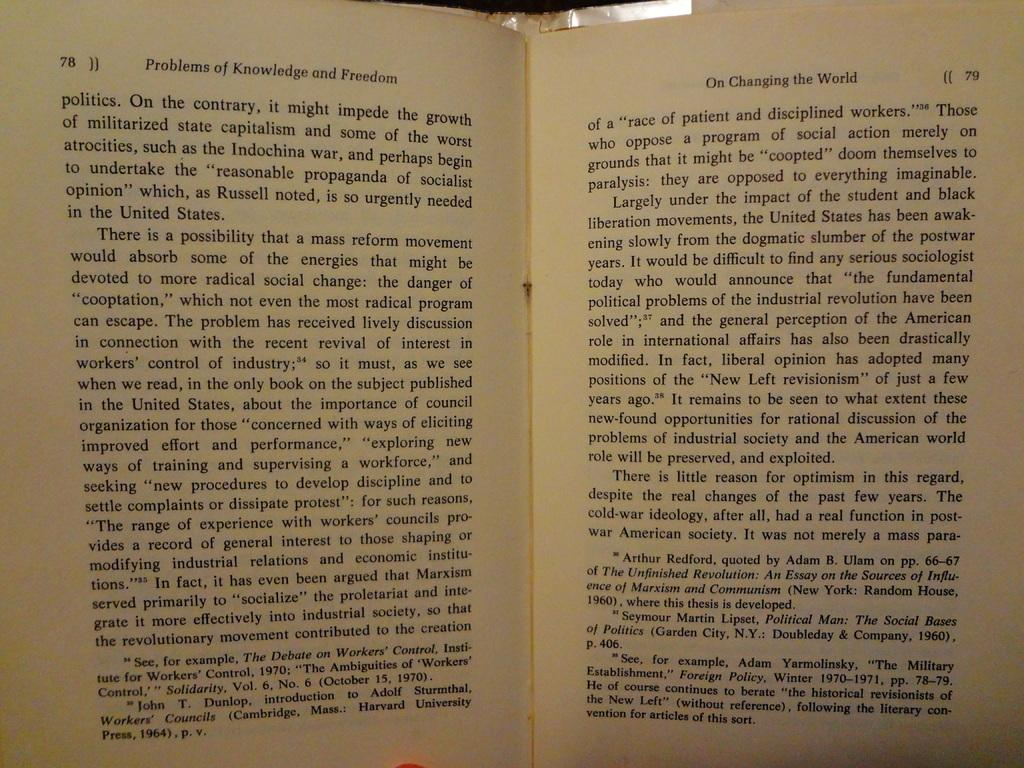<image>
Present a compact description of the photo's key features. A book open to page 78 is titled Problems of Knowledge and Freedom 